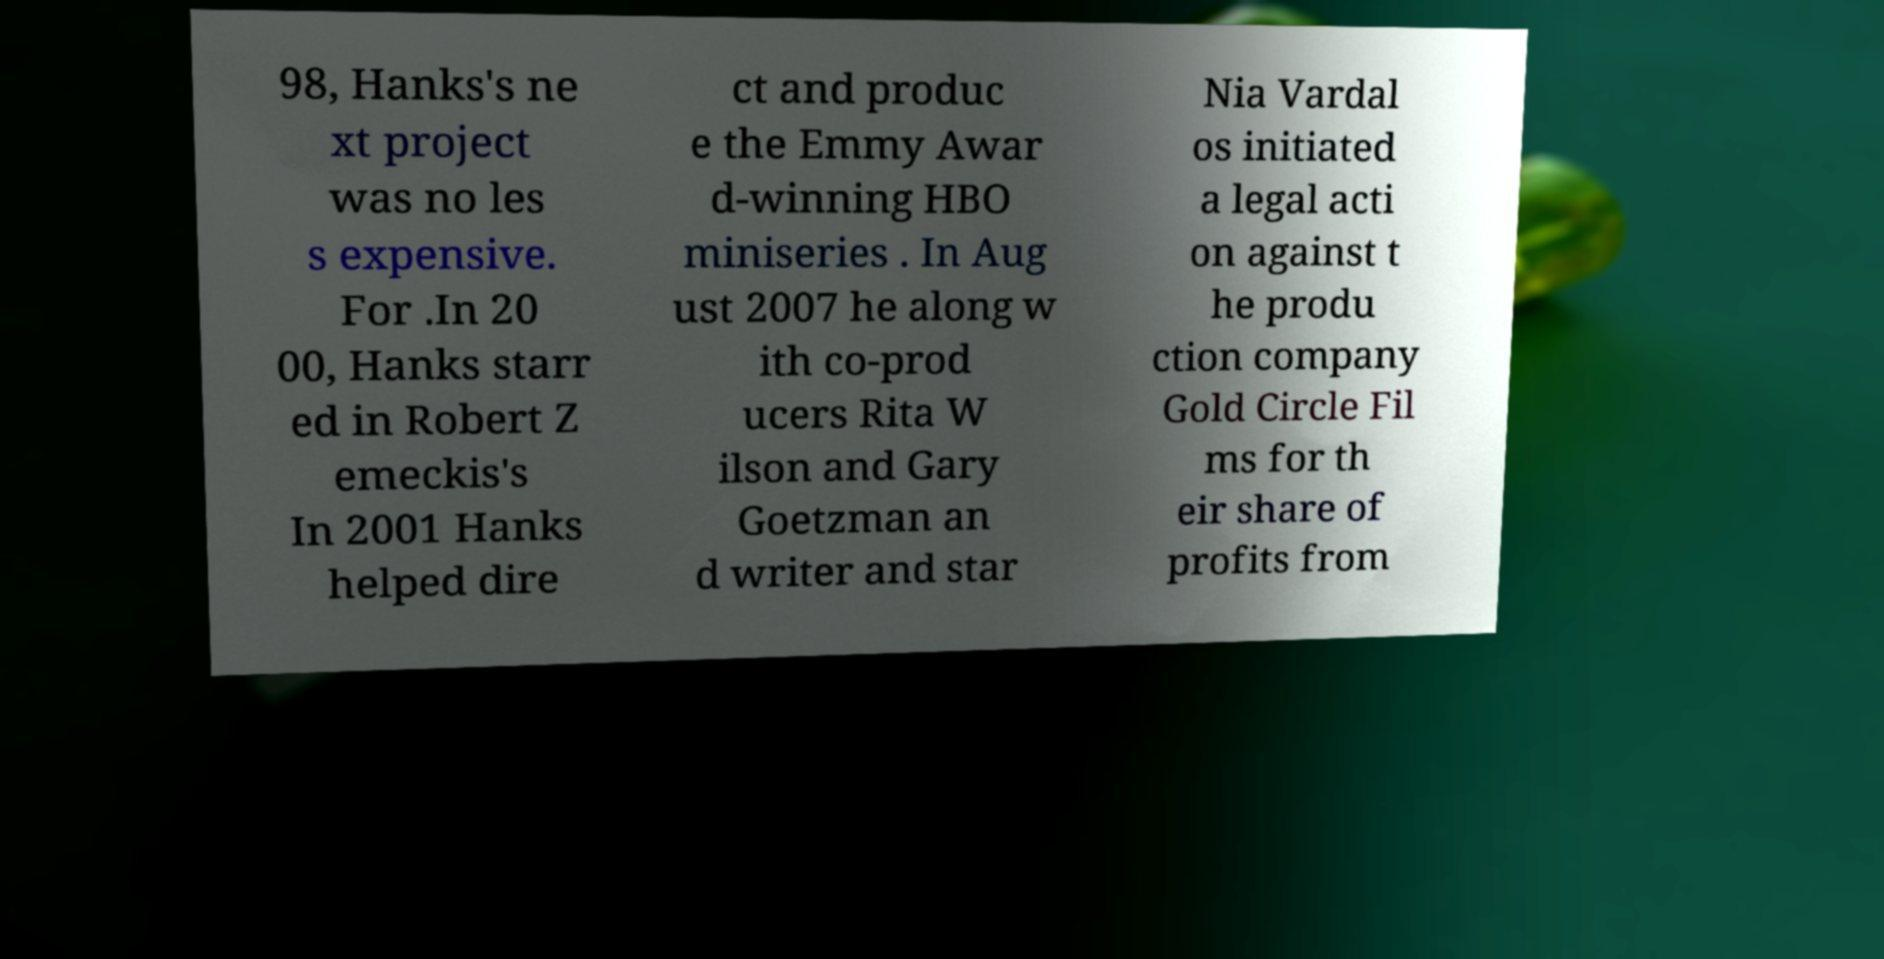Could you extract and type out the text from this image? 98, Hanks's ne xt project was no les s expensive. For .In 20 00, Hanks starr ed in Robert Z emeckis's In 2001 Hanks helped dire ct and produc e the Emmy Awar d-winning HBO miniseries . In Aug ust 2007 he along w ith co-prod ucers Rita W ilson and Gary Goetzman an d writer and star Nia Vardal os initiated a legal acti on against t he produ ction company Gold Circle Fil ms for th eir share of profits from 